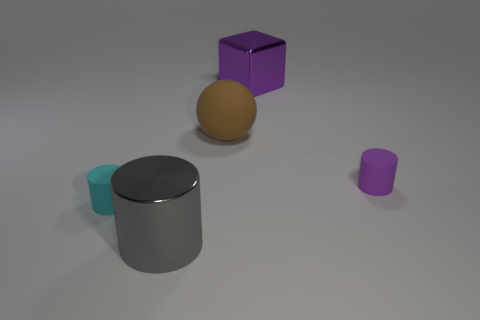There is a thing that is behind the tiny purple matte thing and in front of the large cube; what shape is it?
Your answer should be compact. Sphere. Is there another big cylinder made of the same material as the cyan cylinder?
Your answer should be very brief. No. Is the material of the large thing left of the brown sphere the same as the purple thing that is left of the tiny purple rubber thing?
Give a very brief answer. Yes. Is the number of big gray things greater than the number of small brown cubes?
Your answer should be compact. Yes. The small thing to the right of the tiny cylinder that is left of the rubber object that is to the right of the large brown thing is what color?
Provide a succinct answer. Purple. There is a tiny object that is on the right side of the large metal cylinder; is it the same color as the matte thing that is left of the metallic cylinder?
Give a very brief answer. No. There is a purple rubber object to the right of the purple metal thing; what number of cyan things are behind it?
Offer a terse response. 0. Are any cyan objects visible?
Give a very brief answer. Yes. How many other things are there of the same color as the large cube?
Provide a short and direct response. 1. Is the number of large rubber balls less than the number of green spheres?
Keep it short and to the point. No. 